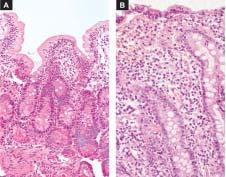what is there with reduction in their height?
Answer the question using a single word or phrase. Shortening and blunting of the villi 